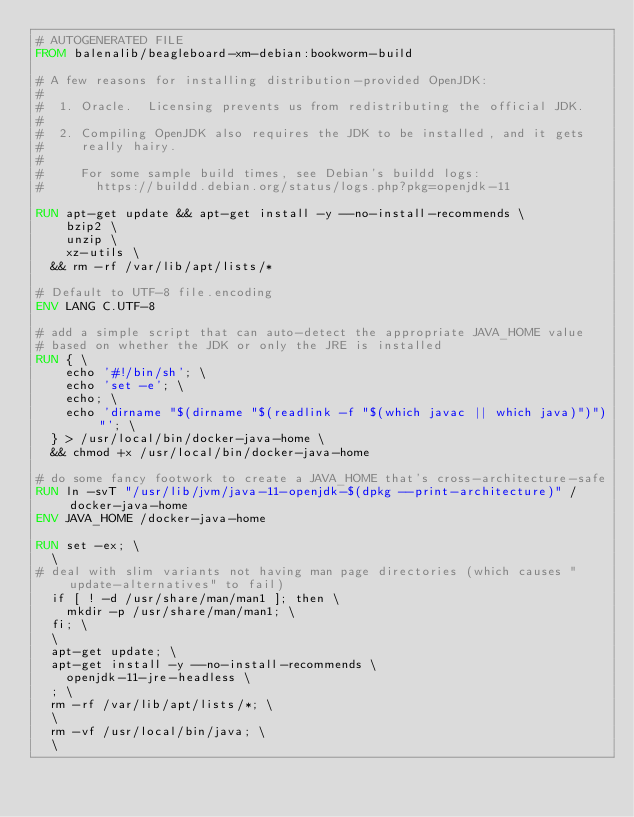Convert code to text. <code><loc_0><loc_0><loc_500><loc_500><_Dockerfile_># AUTOGENERATED FILE
FROM balenalib/beagleboard-xm-debian:bookworm-build

# A few reasons for installing distribution-provided OpenJDK:
#
#  1. Oracle.  Licensing prevents us from redistributing the official JDK.
#
#  2. Compiling OpenJDK also requires the JDK to be installed, and it gets
#     really hairy.
#
#     For some sample build times, see Debian's buildd logs:
#       https://buildd.debian.org/status/logs.php?pkg=openjdk-11

RUN apt-get update && apt-get install -y --no-install-recommends \
		bzip2 \
		unzip \
		xz-utils \
	&& rm -rf /var/lib/apt/lists/*

# Default to UTF-8 file.encoding
ENV LANG C.UTF-8

# add a simple script that can auto-detect the appropriate JAVA_HOME value
# based on whether the JDK or only the JRE is installed
RUN { \
		echo '#!/bin/sh'; \
		echo 'set -e'; \
		echo; \
		echo 'dirname "$(dirname "$(readlink -f "$(which javac || which java)")")"'; \
	} > /usr/local/bin/docker-java-home \
	&& chmod +x /usr/local/bin/docker-java-home

# do some fancy footwork to create a JAVA_HOME that's cross-architecture-safe
RUN ln -svT "/usr/lib/jvm/java-11-openjdk-$(dpkg --print-architecture)" /docker-java-home
ENV JAVA_HOME /docker-java-home

RUN set -ex; \
	\
# deal with slim variants not having man page directories (which causes "update-alternatives" to fail)
	if [ ! -d /usr/share/man/man1 ]; then \
		mkdir -p /usr/share/man/man1; \
	fi; \
	\
	apt-get update; \
	apt-get install -y --no-install-recommends \
		openjdk-11-jre-headless \
	; \
	rm -rf /var/lib/apt/lists/*; \
	\
	rm -vf /usr/local/bin/java; \
	\</code> 